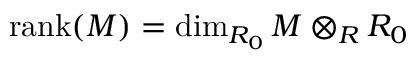<formula> <loc_0><loc_0><loc_500><loc_500>{ r a n k } ( M ) = \dim _ { R _ { 0 } } M \otimes _ { R } R _ { 0 }</formula> 